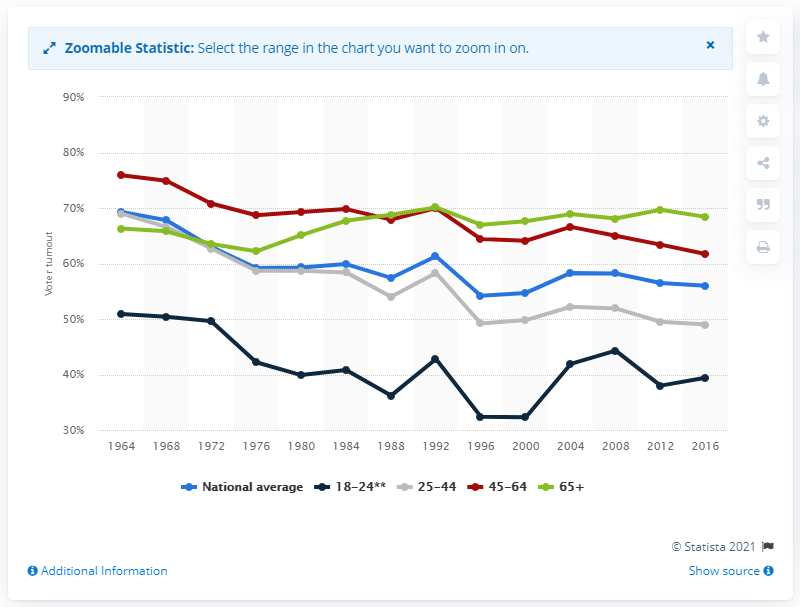Outline some significant characteristics in this image. Since 1964, voter turnout rates have decreased across all age groups. Voter turnout rates began to increase in 1988. 